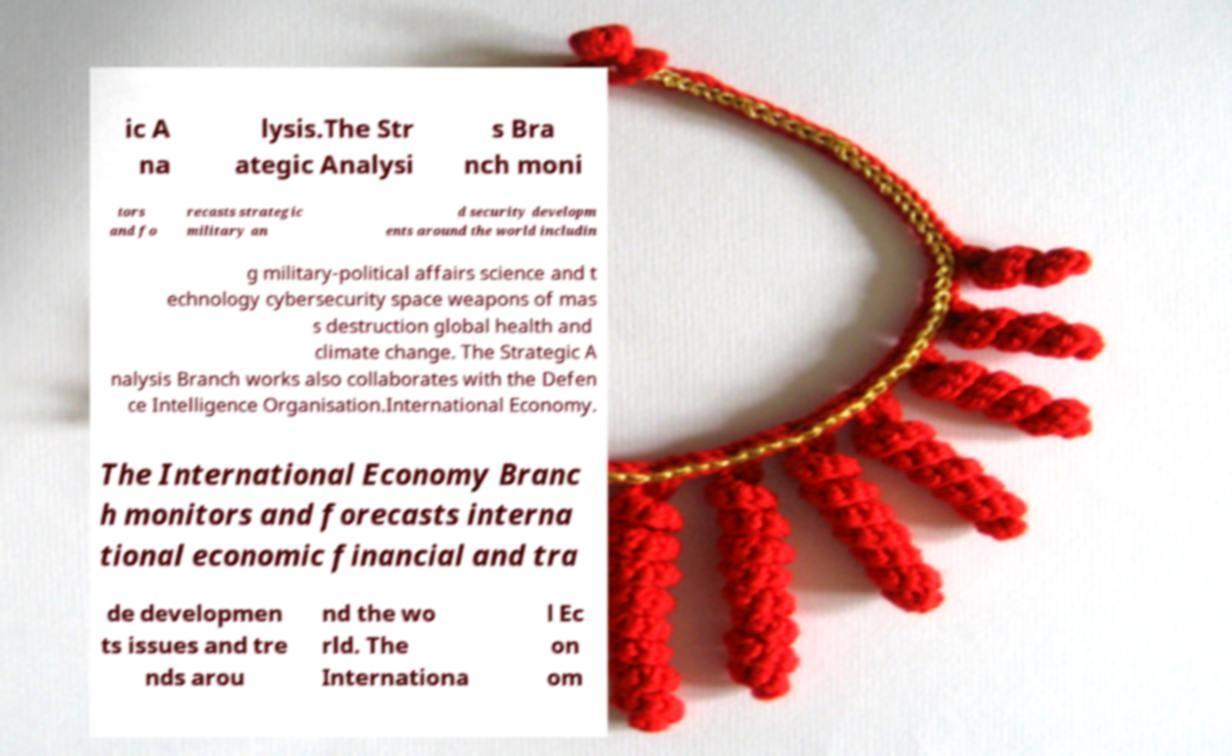Could you assist in decoding the text presented in this image and type it out clearly? ic A na lysis.The Str ategic Analysi s Bra nch moni tors and fo recasts strategic military an d security developm ents around the world includin g military-political affairs science and t echnology cybersecurity space weapons of mas s destruction global health and climate change. The Strategic A nalysis Branch works also collaborates with the Defen ce Intelligence Organisation.International Economy. The International Economy Branc h monitors and forecasts interna tional economic financial and tra de developmen ts issues and tre nds arou nd the wo rld. The Internationa l Ec on om 